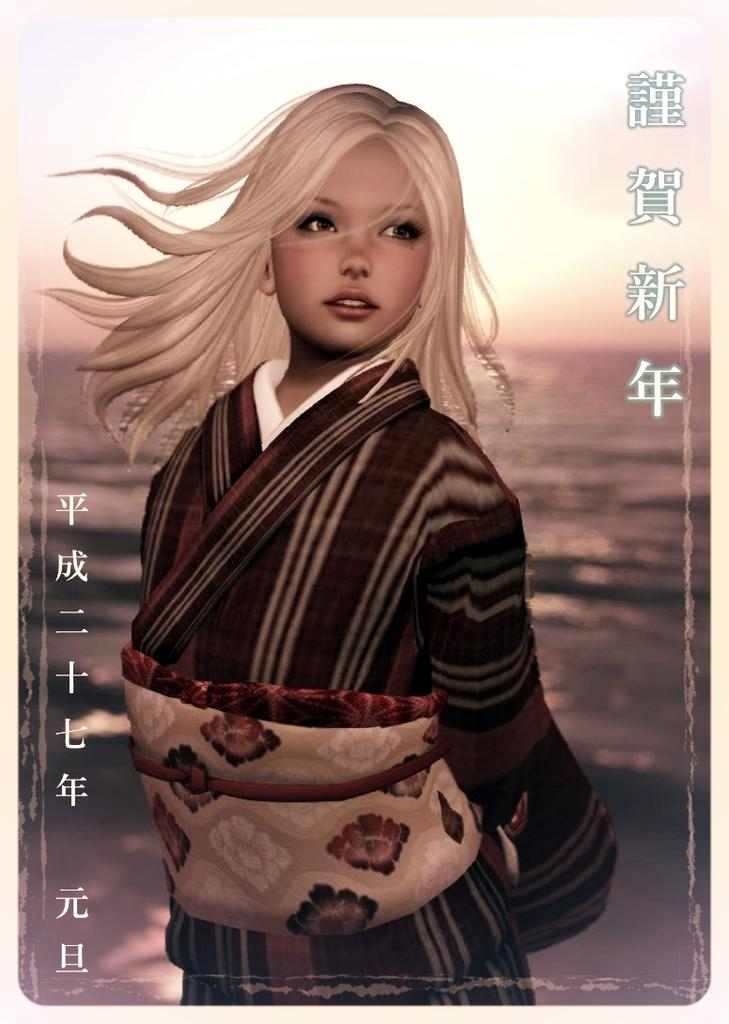What type of picture is the image? The image is an animated picture. Who is present in the image? There is a girl in the image. What is the girl wearing? The girl is wearing a dress. What can be seen behind the girl? There is water visible behind the girl. What type of toy is the girl playing with in the image? There is no toy visible in the image; the girl is not shown playing with anything. 